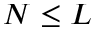<formula> <loc_0><loc_0><loc_500><loc_500>N \leq L</formula> 